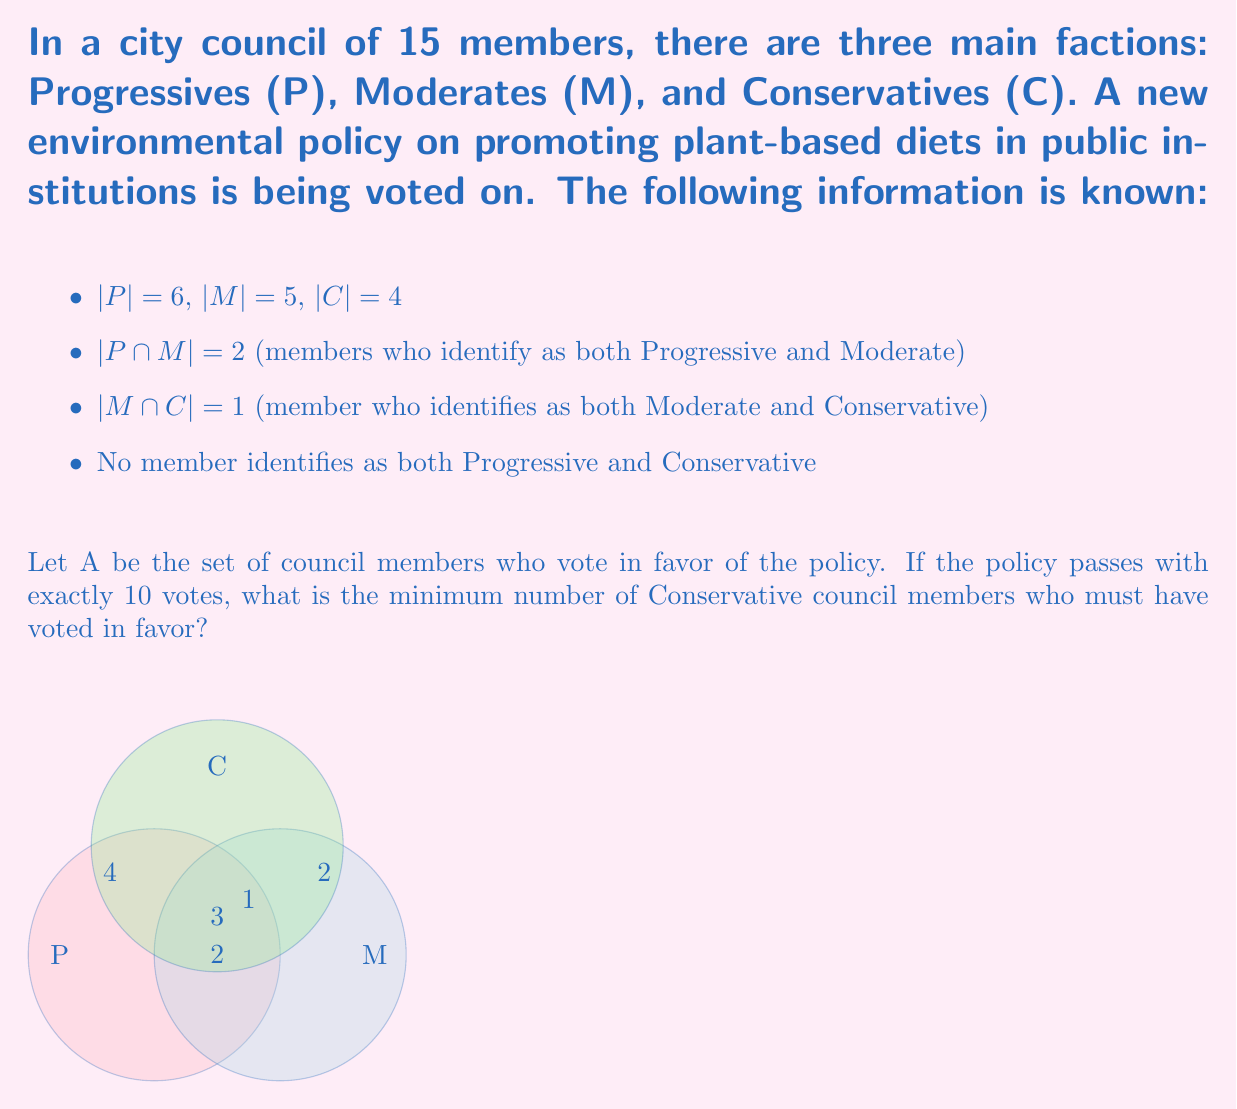Can you answer this question? Let's approach this step-by-step:

1) First, we need to calculate the total number of unique council members:
   $|P \cup M \cup C| = |P| + |M| + |C| - |P \cap M| - |M \cap C| - |P \cap C| + |P \cap M \cap C|$
   $= 6 + 5 + 4 - 2 - 1 - 0 + 0 = 12$

2) Now, we know that 10 members voted in favor out of 12 total members.

3) Let's define subsets:
   $P_f$ = Progressives voting in favor
   $M_f$ = Moderates voting in favor
   $C_f$ = Conservatives voting in favor

4) We know that $|P_f| + |M_f| + |C_f| = 10$

5) To minimize $|C_f|$, we need to maximize $|P_f|$ and $|M_f|$:
   $|P_f| \leq 6$ (total Progressives)
   $|M_f| \leq 5$ (total Moderates)

6) Even if all Progressives and Moderates vote in favor, we have:
   $6 + 5 = 11$ potential votes, but remember that 2 members are in both P and M.

7) So the maximum number of non-Conservative votes is actually:
   $6 + 5 - 2 = 9$

8) Therefore, to reach 10 votes, at least one Conservative must vote in favor.

Thus, the minimum number of Conservative council members who must have voted in favor is 1.
Answer: 1 